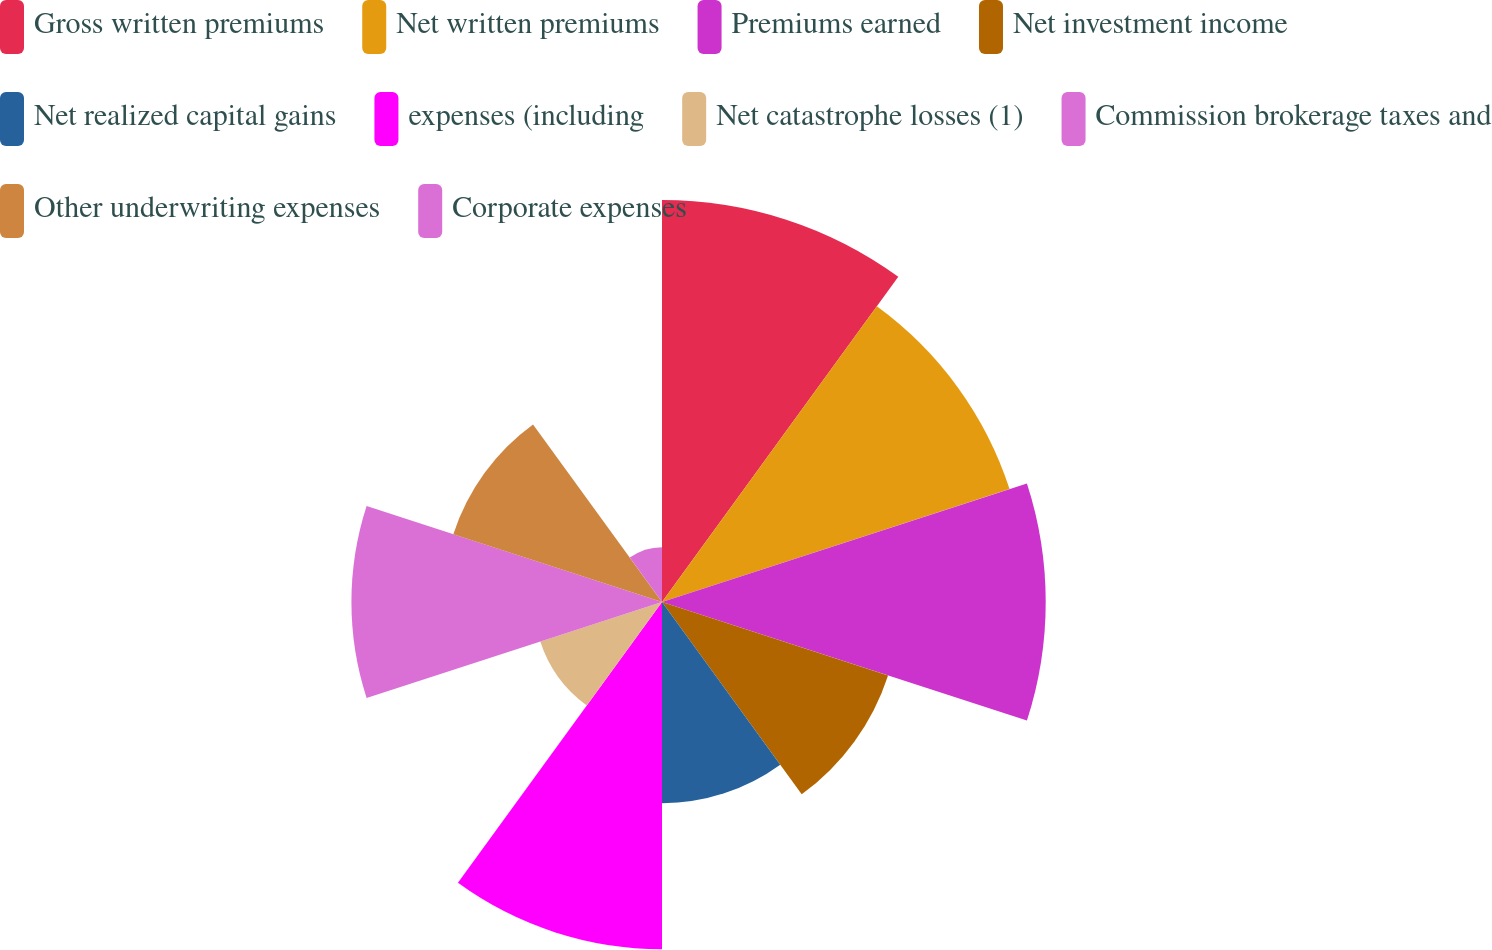Convert chart to OTSL. <chart><loc_0><loc_0><loc_500><loc_500><pie_chart><fcel>Gross written premiums<fcel>Net written premiums<fcel>Premiums earned<fcel>Net investment income<fcel>Net realized capital gains<fcel>expenses (including<fcel>Net catastrophe losses (1)<fcel>Commission brokerage taxes and<fcel>Other underwriting expenses<fcel>Corporate expenses<nl><fcel>15.17%<fcel>13.79%<fcel>14.48%<fcel>8.97%<fcel>7.59%<fcel>13.1%<fcel>4.83%<fcel>11.72%<fcel>8.28%<fcel>2.07%<nl></chart> 